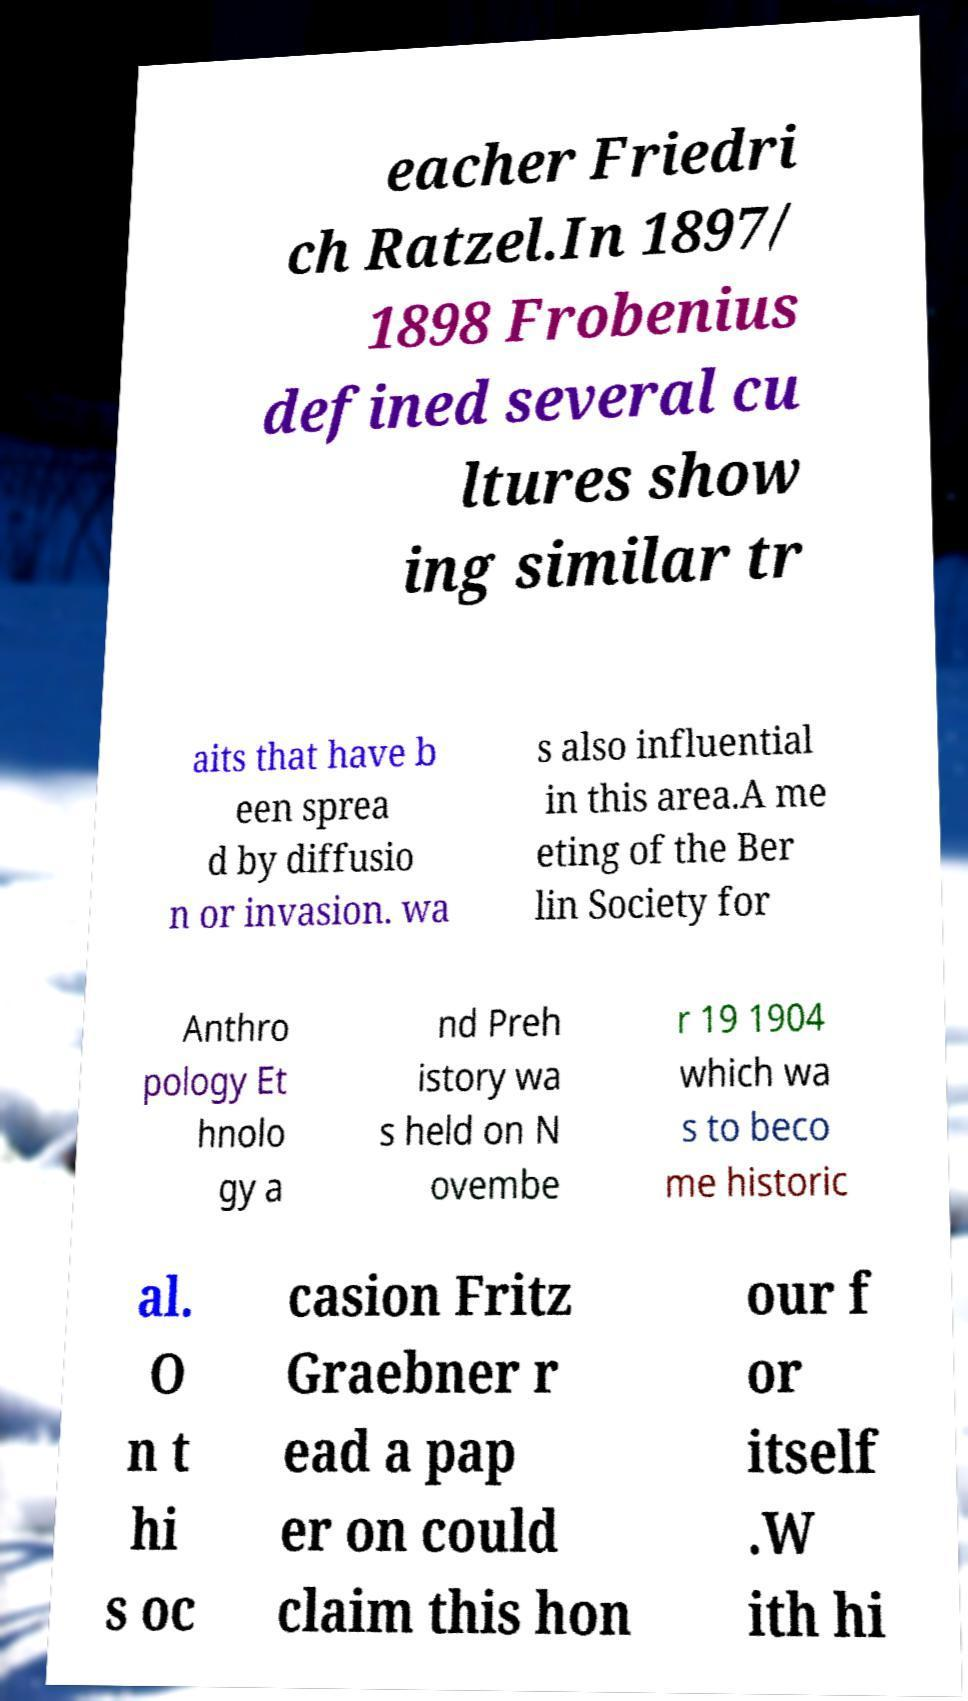For documentation purposes, I need the text within this image transcribed. Could you provide that? eacher Friedri ch Ratzel.In 1897/ 1898 Frobenius defined several cu ltures show ing similar tr aits that have b een sprea d by diffusio n or invasion. wa s also influential in this area.A me eting of the Ber lin Society for Anthro pology Et hnolo gy a nd Preh istory wa s held on N ovembe r 19 1904 which wa s to beco me historic al. O n t hi s oc casion Fritz Graebner r ead a pap er on could claim this hon our f or itself .W ith hi 